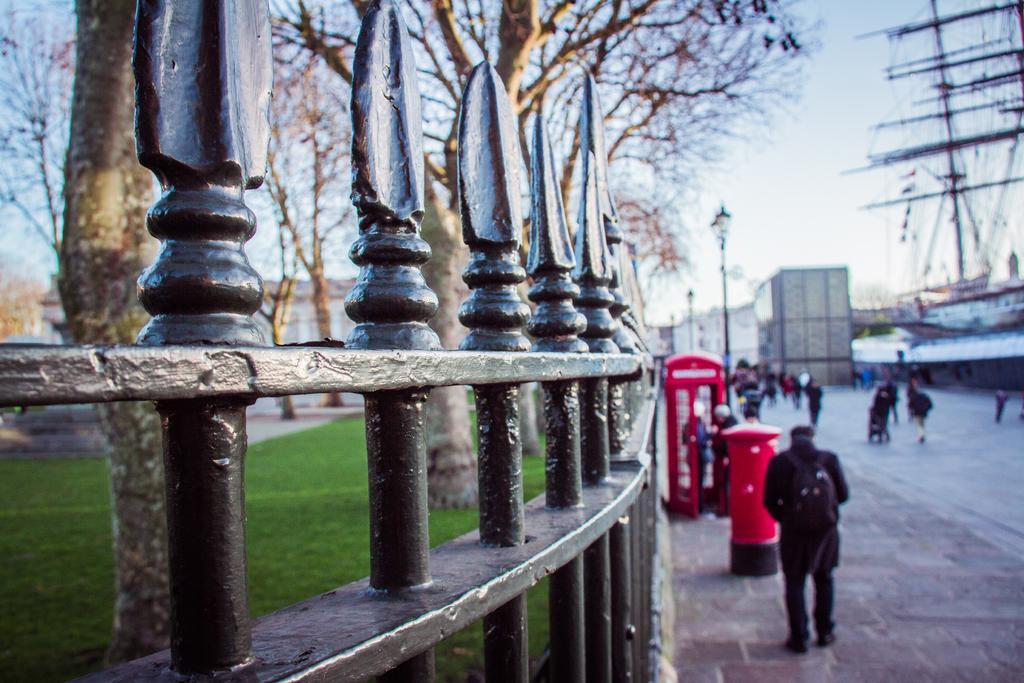How would you summarize this image in a sentence or two? In this image we can see some group of persons walking on the road, there is telephone both, post box, on left side of the image there is fencing, there are some trees and on right side of the image there are some houses and clear sky. 